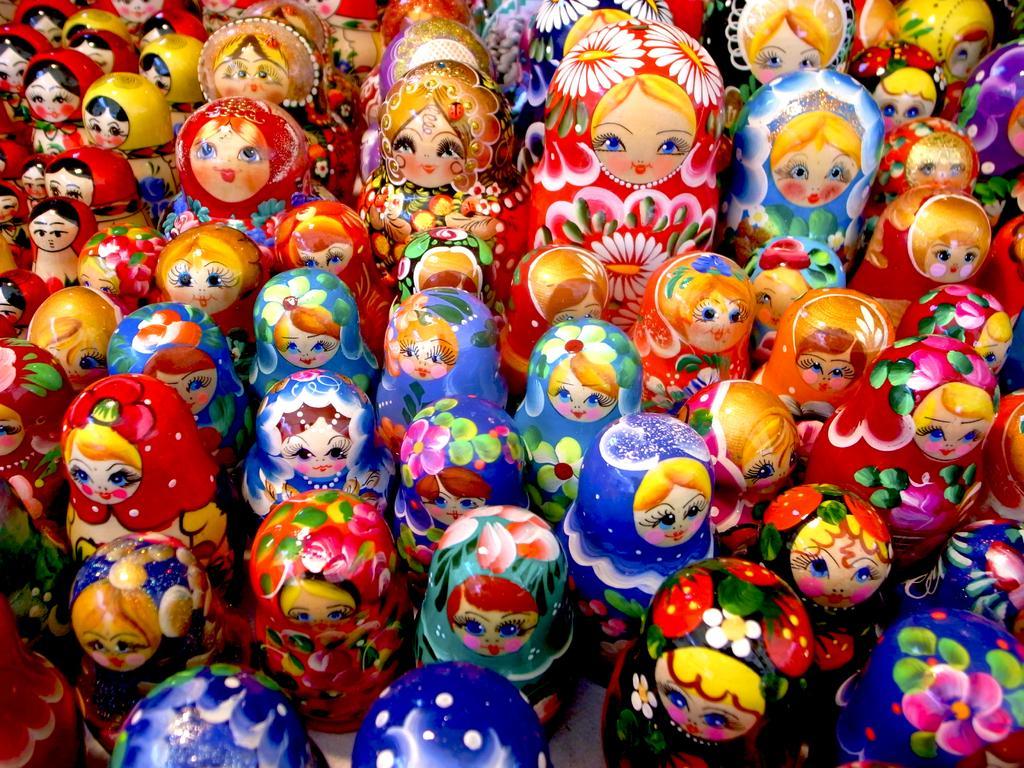Could you give a brief overview of what you see in this image? In this picture we can see wooden painted dolls. 